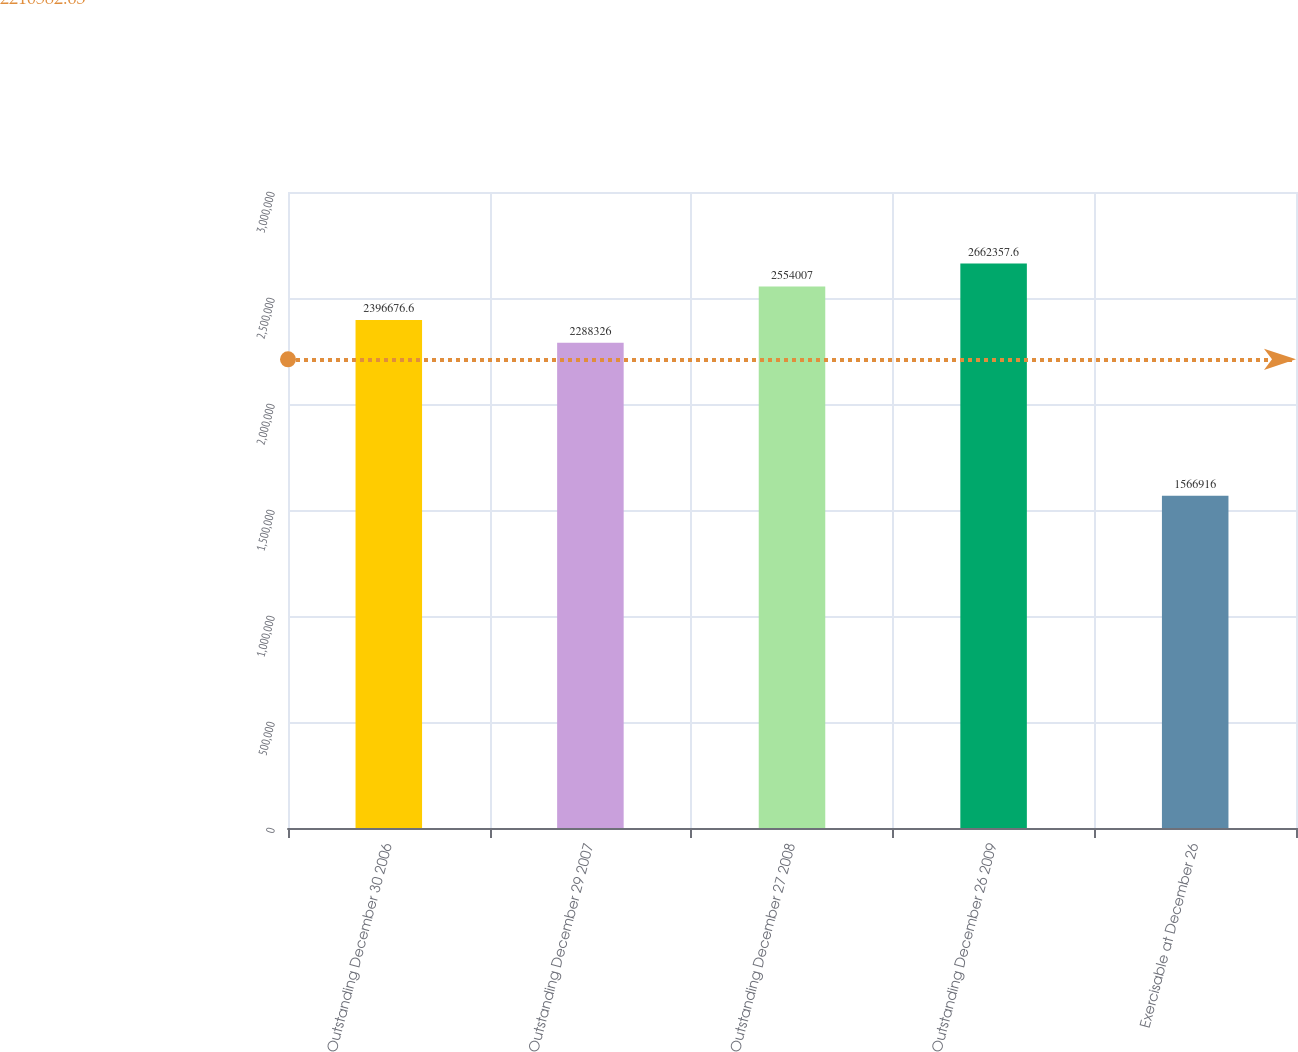<chart> <loc_0><loc_0><loc_500><loc_500><bar_chart><fcel>Outstanding December 30 2006<fcel>Outstanding December 29 2007<fcel>Outstanding December 27 2008<fcel>Outstanding December 26 2009<fcel>Exercisable at December 26<nl><fcel>2.39668e+06<fcel>2.28833e+06<fcel>2.55401e+06<fcel>2.66236e+06<fcel>1.56692e+06<nl></chart> 